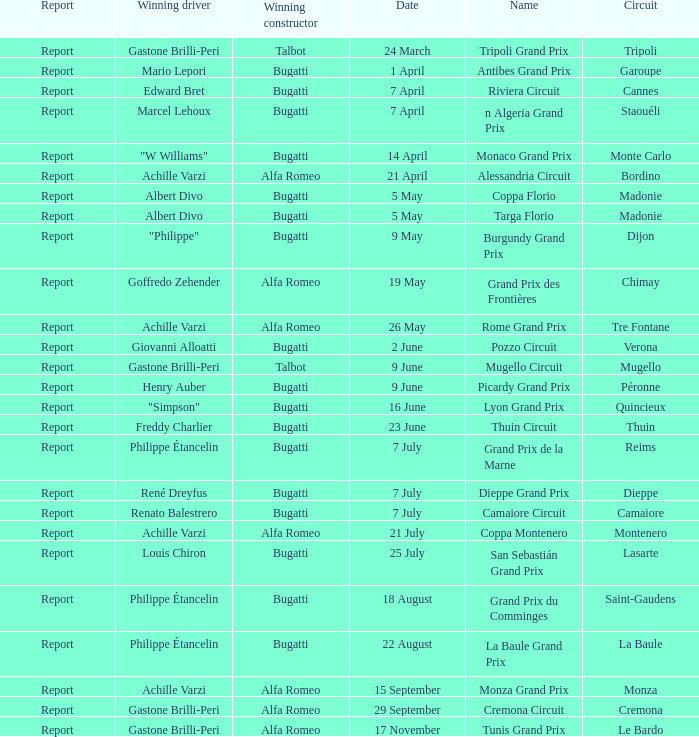Which successful driver has a winning constructor in talbot? Gastone Brilli-Peri, Gastone Brilli-Peri. 